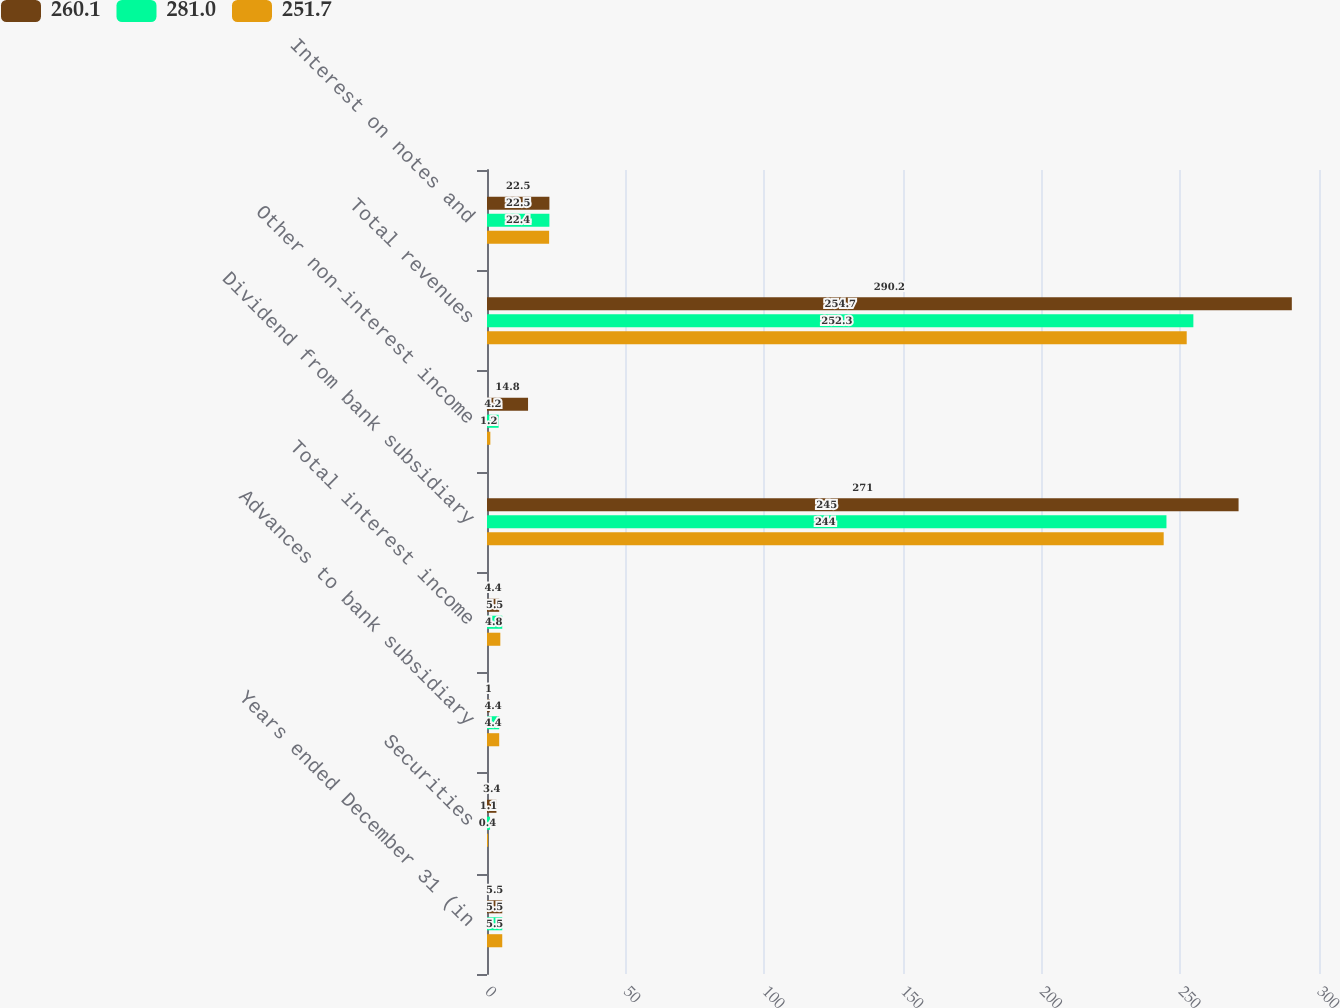Convert chart to OTSL. <chart><loc_0><loc_0><loc_500><loc_500><stacked_bar_chart><ecel><fcel>Years ended December 31 (in<fcel>Securities<fcel>Advances to bank subsidiary<fcel>Total interest income<fcel>Dividend from bank subsidiary<fcel>Other non-interest income<fcel>Total revenues<fcel>Interest on notes and<nl><fcel>260.1<fcel>5.5<fcel>3.4<fcel>1<fcel>4.4<fcel>271<fcel>14.8<fcel>290.2<fcel>22.5<nl><fcel>281<fcel>5.5<fcel>1.1<fcel>4.4<fcel>5.5<fcel>245<fcel>4.2<fcel>254.7<fcel>22.5<nl><fcel>251.7<fcel>5.5<fcel>0.4<fcel>4.4<fcel>4.8<fcel>244<fcel>1.2<fcel>252.3<fcel>22.4<nl></chart> 